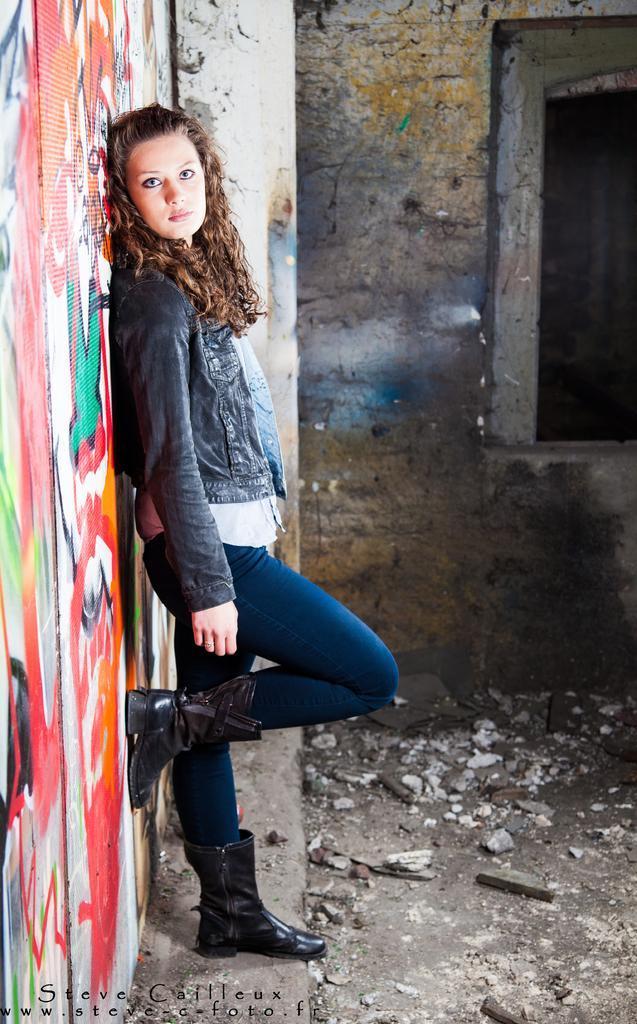Describe this image in one or two sentences. In this image I can see the person wearing the white and blue color dress. At the back of the person I can see the wall with painting. In the background there is a window to the wall. 